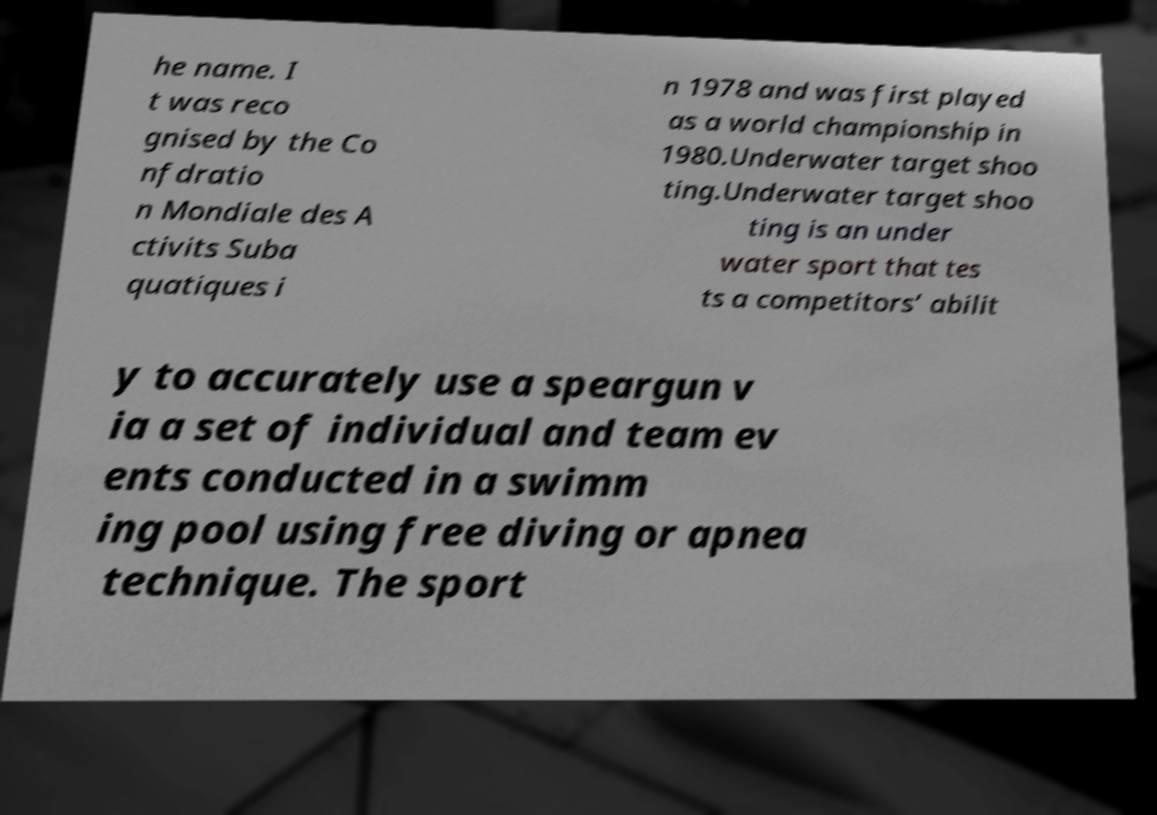Could you assist in decoding the text presented in this image and type it out clearly? he name. I t was reco gnised by the Co nfdratio n Mondiale des A ctivits Suba quatiques i n 1978 and was first played as a world championship in 1980.Underwater target shoo ting.Underwater target shoo ting is an under water sport that tes ts a competitors’ abilit y to accurately use a speargun v ia a set of individual and team ev ents conducted in a swimm ing pool using free diving or apnea technique. The sport 